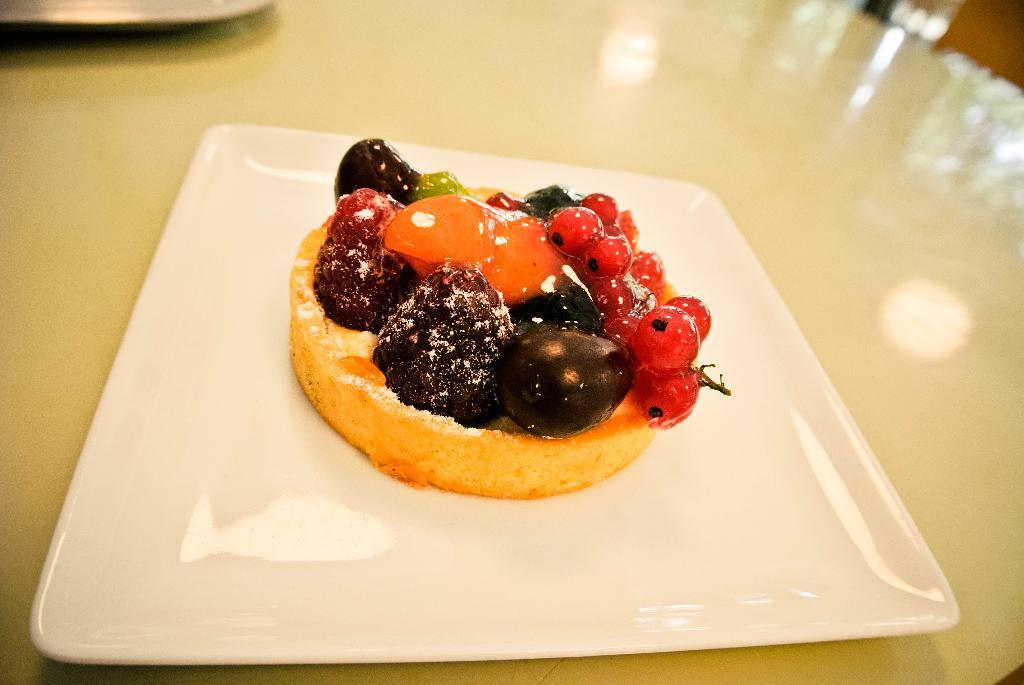What object is present on the table in the image? There is a plate on the table in the image. What is the purpose of the plate in the image? The plate is used to hold food. What can be found on the plate in the image? There is food on the plate. What type of cannon is depicted on the plate in the image? There is no cannon present on the plate or in the image. How does the peace symbol relate to the food on the plate in the image? There is no peace symbol present in the image, and therefore no relation to the food can be established. 